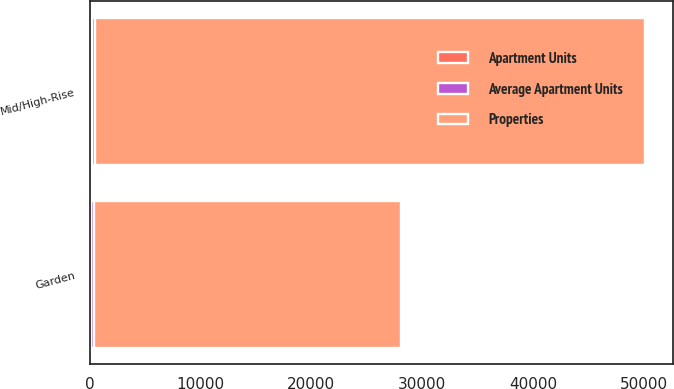Convert chart to OTSL. <chart><loc_0><loc_0><loc_500><loc_500><stacked_bar_chart><ecel><fcel>Garden<fcel>Mid/High-Rise<nl><fcel>Apartment Units<fcel>110<fcel>192<nl><fcel>Properties<fcel>27769<fcel>49689<nl><fcel>Average Apartment Units<fcel>252<fcel>259<nl></chart> 